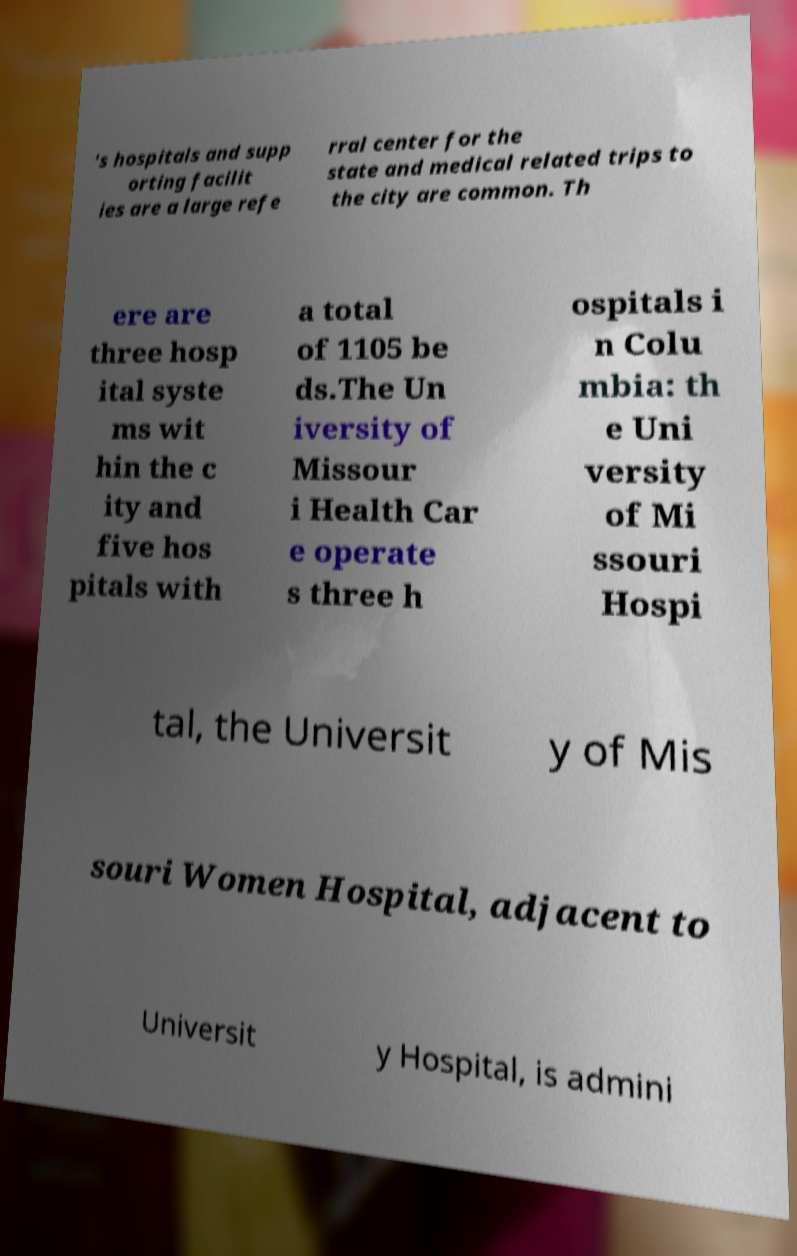For documentation purposes, I need the text within this image transcribed. Could you provide that? 's hospitals and supp orting facilit ies are a large refe rral center for the state and medical related trips to the city are common. Th ere are three hosp ital syste ms wit hin the c ity and five hos pitals with a total of 1105 be ds.The Un iversity of Missour i Health Car e operate s three h ospitals i n Colu mbia: th e Uni versity of Mi ssouri Hospi tal, the Universit y of Mis souri Women Hospital, adjacent to Universit y Hospital, is admini 